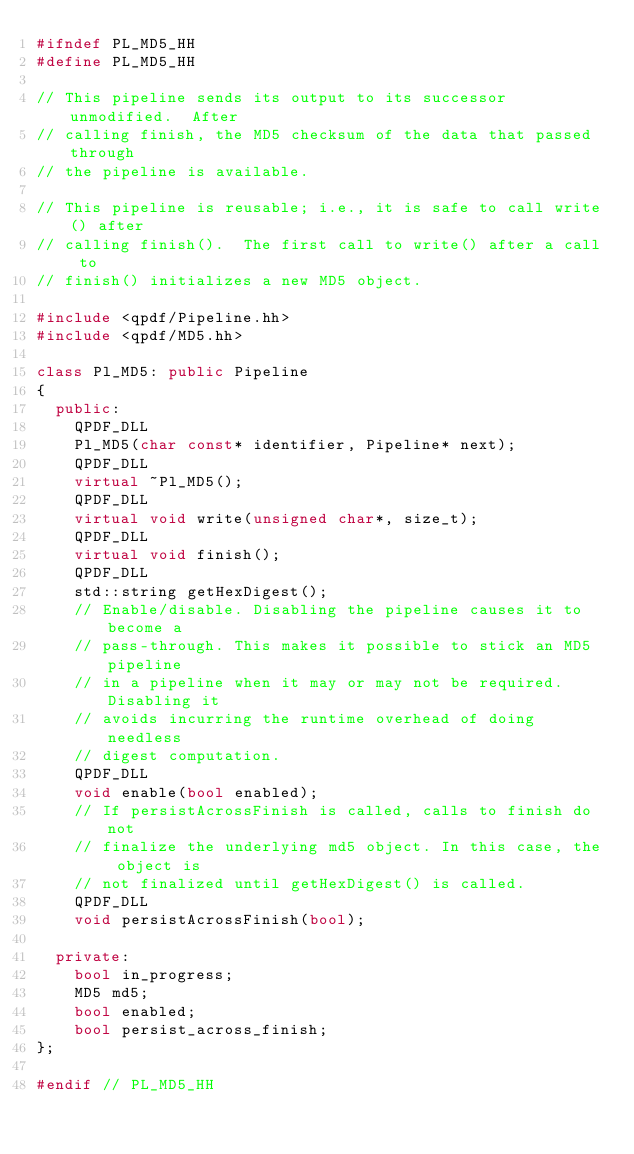<code> <loc_0><loc_0><loc_500><loc_500><_C++_>#ifndef PL_MD5_HH
#define PL_MD5_HH

// This pipeline sends its output to its successor unmodified.  After
// calling finish, the MD5 checksum of the data that passed through
// the pipeline is available.

// This pipeline is reusable; i.e., it is safe to call write() after
// calling finish().  The first call to write() after a call to
// finish() initializes a new MD5 object.

#include <qpdf/Pipeline.hh>
#include <qpdf/MD5.hh>

class Pl_MD5: public Pipeline
{
  public:
    QPDF_DLL
    Pl_MD5(char const* identifier, Pipeline* next);
    QPDF_DLL
    virtual ~Pl_MD5();
    QPDF_DLL
    virtual void write(unsigned char*, size_t);
    QPDF_DLL
    virtual void finish();
    QPDF_DLL
    std::string getHexDigest();
    // Enable/disable. Disabling the pipeline causes it to become a
    // pass-through. This makes it possible to stick an MD5 pipeline
    // in a pipeline when it may or may not be required. Disabling it
    // avoids incurring the runtime overhead of doing needless
    // digest computation.
    QPDF_DLL
    void enable(bool enabled);
    // If persistAcrossFinish is called, calls to finish do not
    // finalize the underlying md5 object. In this case, the object is
    // not finalized until getHexDigest() is called.
    QPDF_DLL
    void persistAcrossFinish(bool);

  private:
    bool in_progress;
    MD5 md5;
    bool enabled;
    bool persist_across_finish;
};

#endif // PL_MD5_HH
</code> 